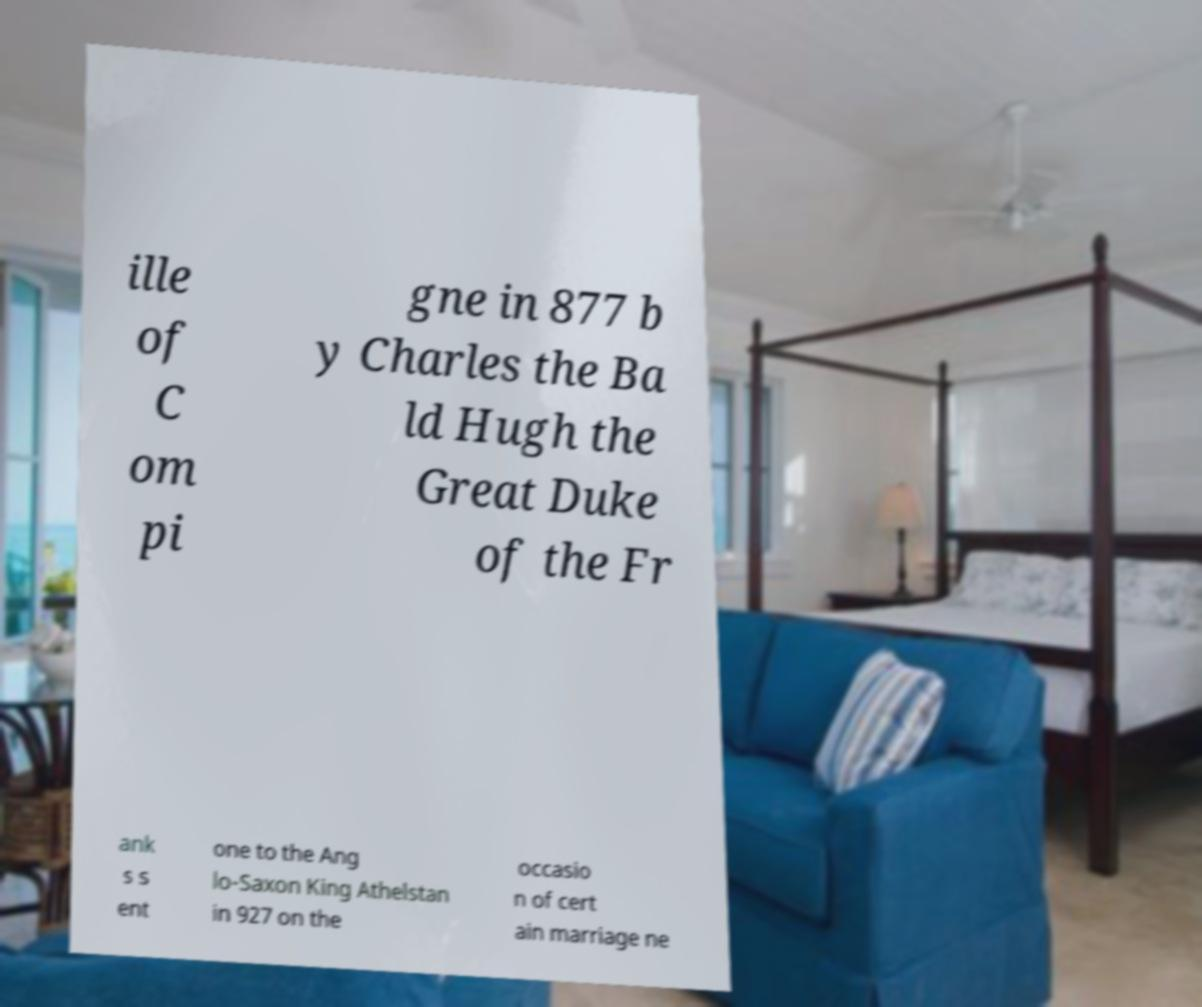For documentation purposes, I need the text within this image transcribed. Could you provide that? ille of C om pi gne in 877 b y Charles the Ba ld Hugh the Great Duke of the Fr ank s s ent one to the Ang lo-Saxon King Athelstan in 927 on the occasio n of cert ain marriage ne 